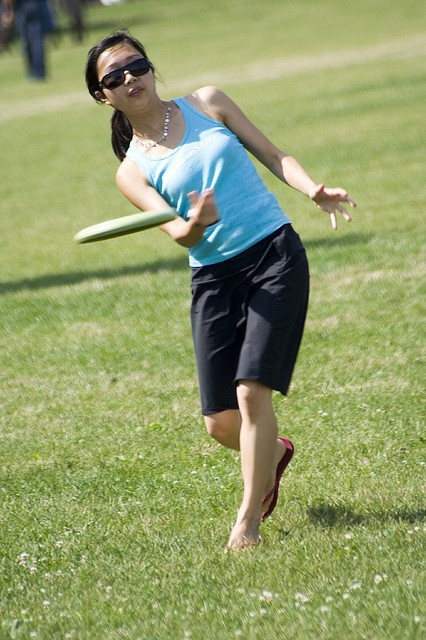Describe the objects in this image and their specific colors. I can see people in black, gray, white, and lightblue tones and frisbee in black, beige, green, and darkgreen tones in this image. 